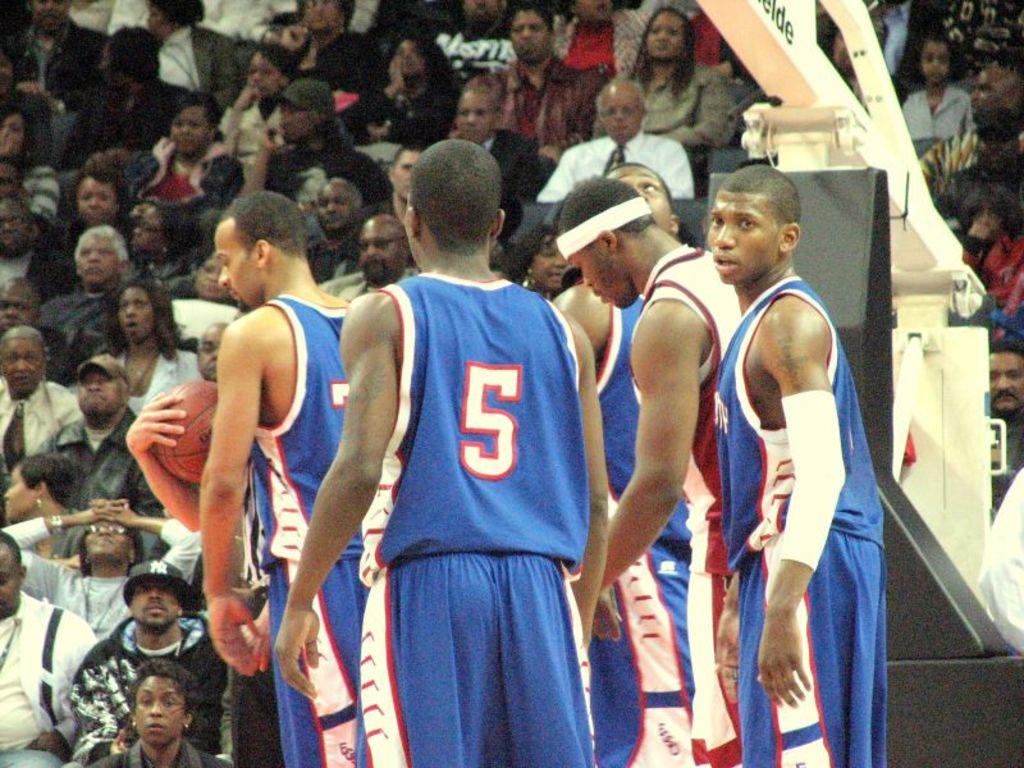<image>
Write a terse but informative summary of the picture. Basketball player wearing jersey number 5 standing on the court. 